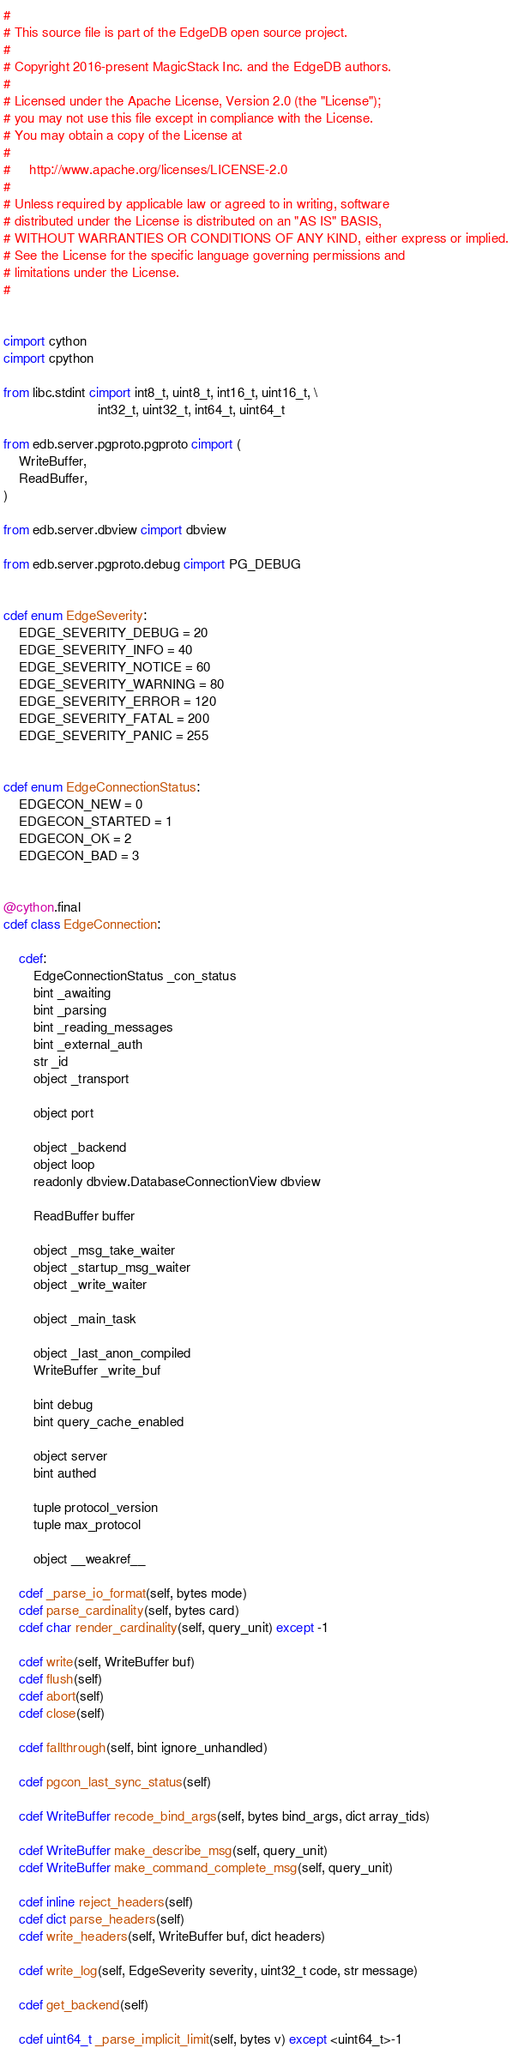Convert code to text. <code><loc_0><loc_0><loc_500><loc_500><_Cython_>#
# This source file is part of the EdgeDB open source project.
#
# Copyright 2016-present MagicStack Inc. and the EdgeDB authors.
#
# Licensed under the Apache License, Version 2.0 (the "License");
# you may not use this file except in compliance with the License.
# You may obtain a copy of the License at
#
#     http://www.apache.org/licenses/LICENSE-2.0
#
# Unless required by applicable law or agreed to in writing, software
# distributed under the License is distributed on an "AS IS" BASIS,
# WITHOUT WARRANTIES OR CONDITIONS OF ANY KIND, either express or implied.
# See the License for the specific language governing permissions and
# limitations under the License.
#


cimport cython
cimport cpython

from libc.stdint cimport int8_t, uint8_t, int16_t, uint16_t, \
                         int32_t, uint32_t, int64_t, uint64_t

from edb.server.pgproto.pgproto cimport (
    WriteBuffer,
    ReadBuffer,
)

from edb.server.dbview cimport dbview

from edb.server.pgproto.debug cimport PG_DEBUG


cdef enum EdgeSeverity:
    EDGE_SEVERITY_DEBUG = 20
    EDGE_SEVERITY_INFO = 40
    EDGE_SEVERITY_NOTICE = 60
    EDGE_SEVERITY_WARNING = 80
    EDGE_SEVERITY_ERROR = 120
    EDGE_SEVERITY_FATAL = 200
    EDGE_SEVERITY_PANIC = 255


cdef enum EdgeConnectionStatus:
    EDGECON_NEW = 0
    EDGECON_STARTED = 1
    EDGECON_OK = 2
    EDGECON_BAD = 3


@cython.final
cdef class EdgeConnection:

    cdef:
        EdgeConnectionStatus _con_status
        bint _awaiting
        bint _parsing
        bint _reading_messages
        bint _external_auth
        str _id
        object _transport

        object port

        object _backend
        object loop
        readonly dbview.DatabaseConnectionView dbview

        ReadBuffer buffer

        object _msg_take_waiter
        object _startup_msg_waiter
        object _write_waiter

        object _main_task

        object _last_anon_compiled
        WriteBuffer _write_buf

        bint debug
        bint query_cache_enabled

        object server
        bint authed

        tuple protocol_version
        tuple max_protocol
        
        object __weakref__

    cdef _parse_io_format(self, bytes mode)
    cdef parse_cardinality(self, bytes card)
    cdef char render_cardinality(self, query_unit) except -1

    cdef write(self, WriteBuffer buf)
    cdef flush(self)
    cdef abort(self)
    cdef close(self)

    cdef fallthrough(self, bint ignore_unhandled)

    cdef pgcon_last_sync_status(self)

    cdef WriteBuffer recode_bind_args(self, bytes bind_args, dict array_tids)

    cdef WriteBuffer make_describe_msg(self, query_unit)
    cdef WriteBuffer make_command_complete_msg(self, query_unit)

    cdef inline reject_headers(self)
    cdef dict parse_headers(self)
    cdef write_headers(self, WriteBuffer buf, dict headers)

    cdef write_log(self, EdgeSeverity severity, uint32_t code, str message)

    cdef get_backend(self)

    cdef uint64_t _parse_implicit_limit(self, bytes v) except <uint64_t>-1
</code> 